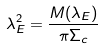Convert formula to latex. <formula><loc_0><loc_0><loc_500><loc_500>\lambda _ { E } ^ { 2 } = \frac { M ( \lambda _ { E } ) } { \pi \Sigma _ { c } }</formula> 